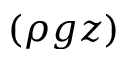<formula> <loc_0><loc_0><loc_500><loc_500>( \rho g z )</formula> 